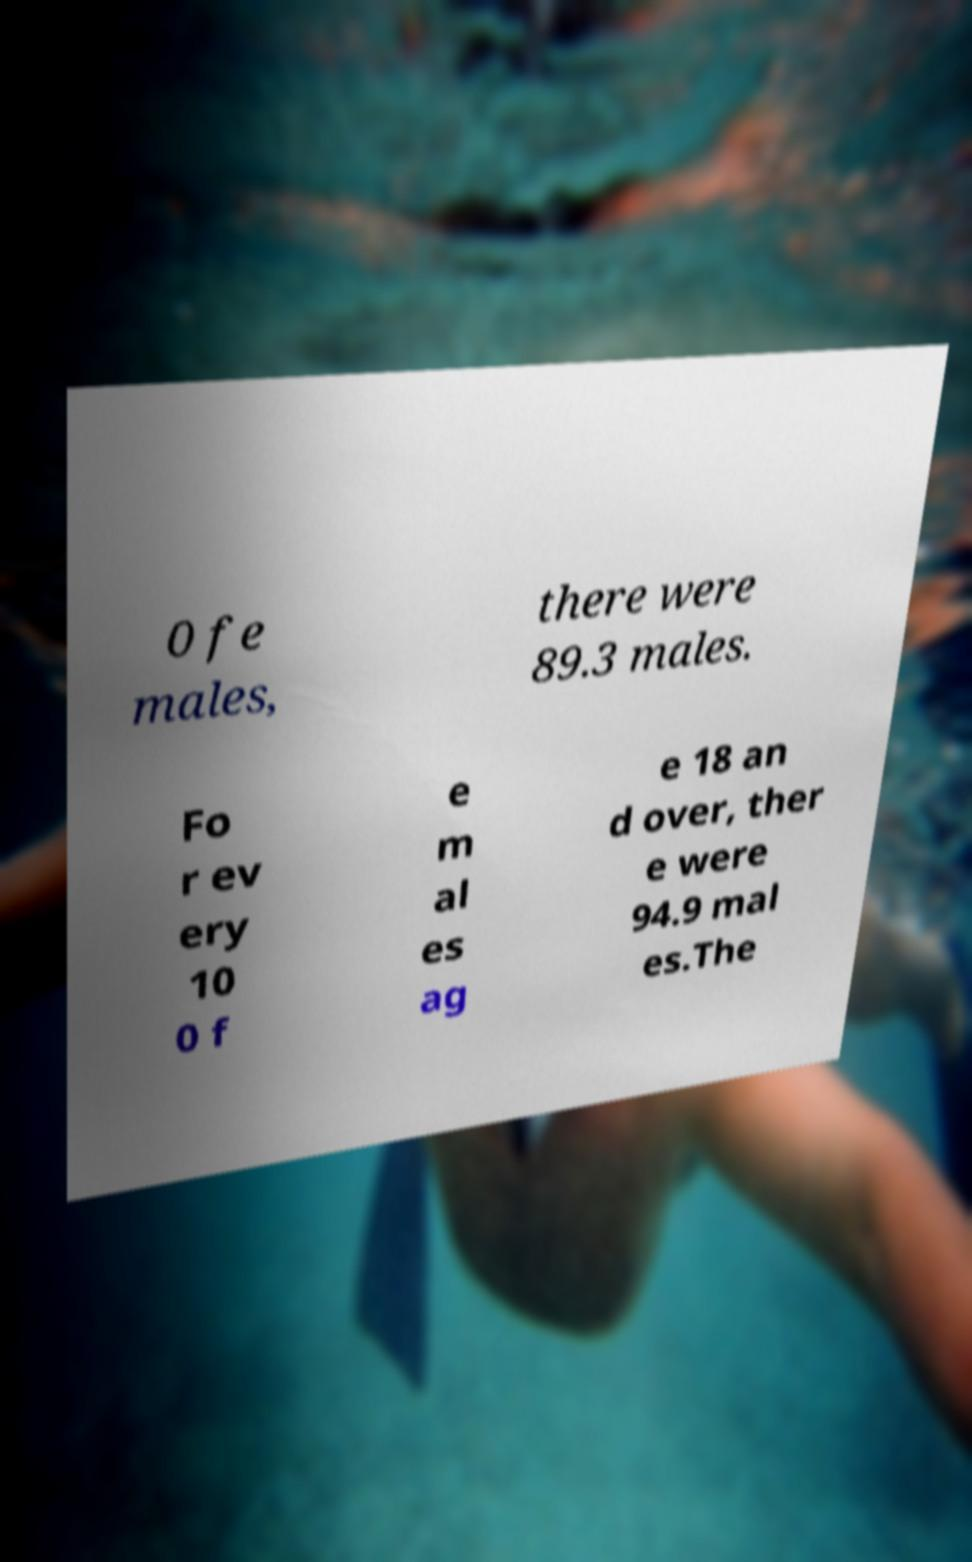Please read and relay the text visible in this image. What does it say? 0 fe males, there were 89.3 males. Fo r ev ery 10 0 f e m al es ag e 18 an d over, ther e were 94.9 mal es.The 